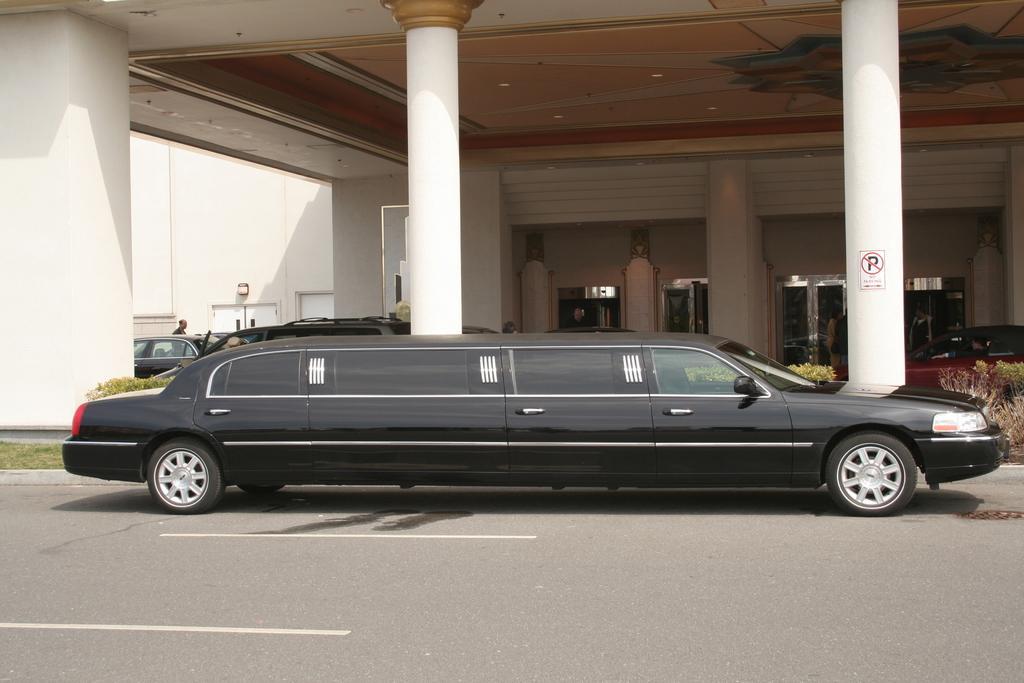How would you summarize this image in a sentence or two? In this picture there is a black color car parked in the front of the hotel. Behind there is a hotel with the big pillars. 